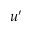Convert formula to latex. <formula><loc_0><loc_0><loc_500><loc_500>u ^ { \prime }</formula> 